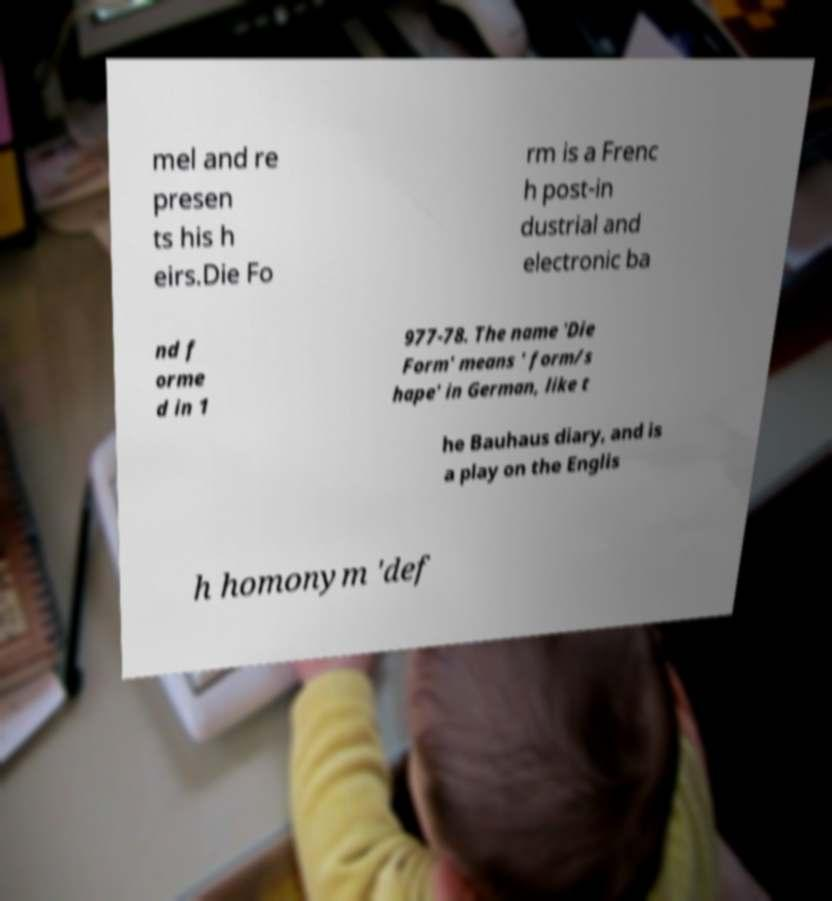Could you assist in decoding the text presented in this image and type it out clearly? mel and re presen ts his h eirs.Die Fo rm is a Frenc h post-in dustrial and electronic ba nd f orme d in 1 977-78. The name 'Die Form' means ' form/s hape' in German, like t he Bauhaus diary, and is a play on the Englis h homonym 'def 